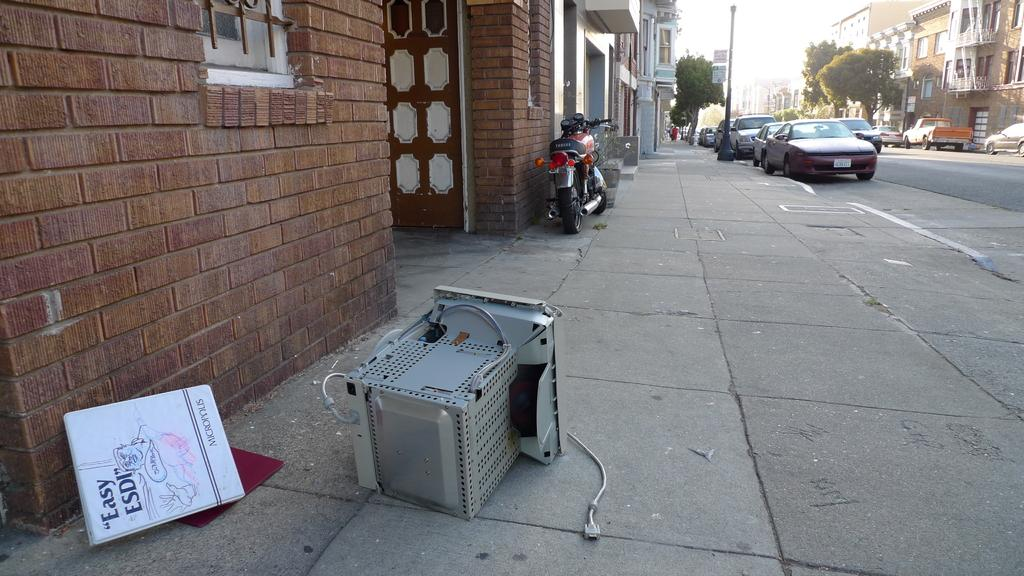What is the main object in the image? There is a machine in the image. What other object is present in the image? There is a bike in the image. Where are the machine and bike located? The machine and bike are kept on the side of a road. What is in front of the machine and bike? There is a building in front of the machine and bike. What can be seen on the road on the right side of the image? There are vehicles visible on the road on the right side of the image. What type of balloon is being used for lunch by the boys in the image? There is no balloon or boys present in the image; it features a machine, a bike, and vehicles on a road. 